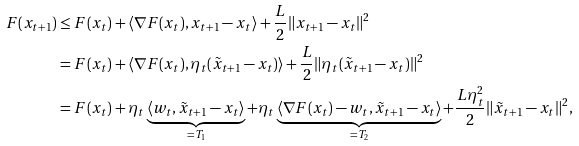Convert formula to latex. <formula><loc_0><loc_0><loc_500><loc_500>F ( x _ { t + 1 } ) & \leq F ( x _ { t } ) + \langle \nabla F ( x _ { t } ) , x _ { t + 1 } - x _ { t } \rangle + \frac { L } { 2 } \| x _ { t + 1 } - x _ { t } \| ^ { 2 } \\ & = F ( x _ { t } ) + \langle \nabla F ( x _ { t } ) , \eta _ { t } ( \tilde { x } _ { t + 1 } - x _ { t } ) \rangle + \frac { L } { 2 } \| \eta _ { t } ( \tilde { x } _ { t + 1 } - x _ { t } ) \| ^ { 2 } \\ & = F ( x _ { t } ) + \eta _ { t } \underbrace { \langle w _ { t } , \tilde { x } _ { t + 1 } - x _ { t } \rangle } _ { = T _ { 1 } } + \eta _ { t } \underbrace { \langle \nabla F ( x _ { t } ) - w _ { t } , \tilde { x } _ { t + 1 } - x _ { t } \rangle } _ { = T _ { 2 } } + \frac { L \eta _ { t } ^ { 2 } } { 2 } \| \tilde { x } _ { t + 1 } - x _ { t } \| ^ { 2 } ,</formula> 